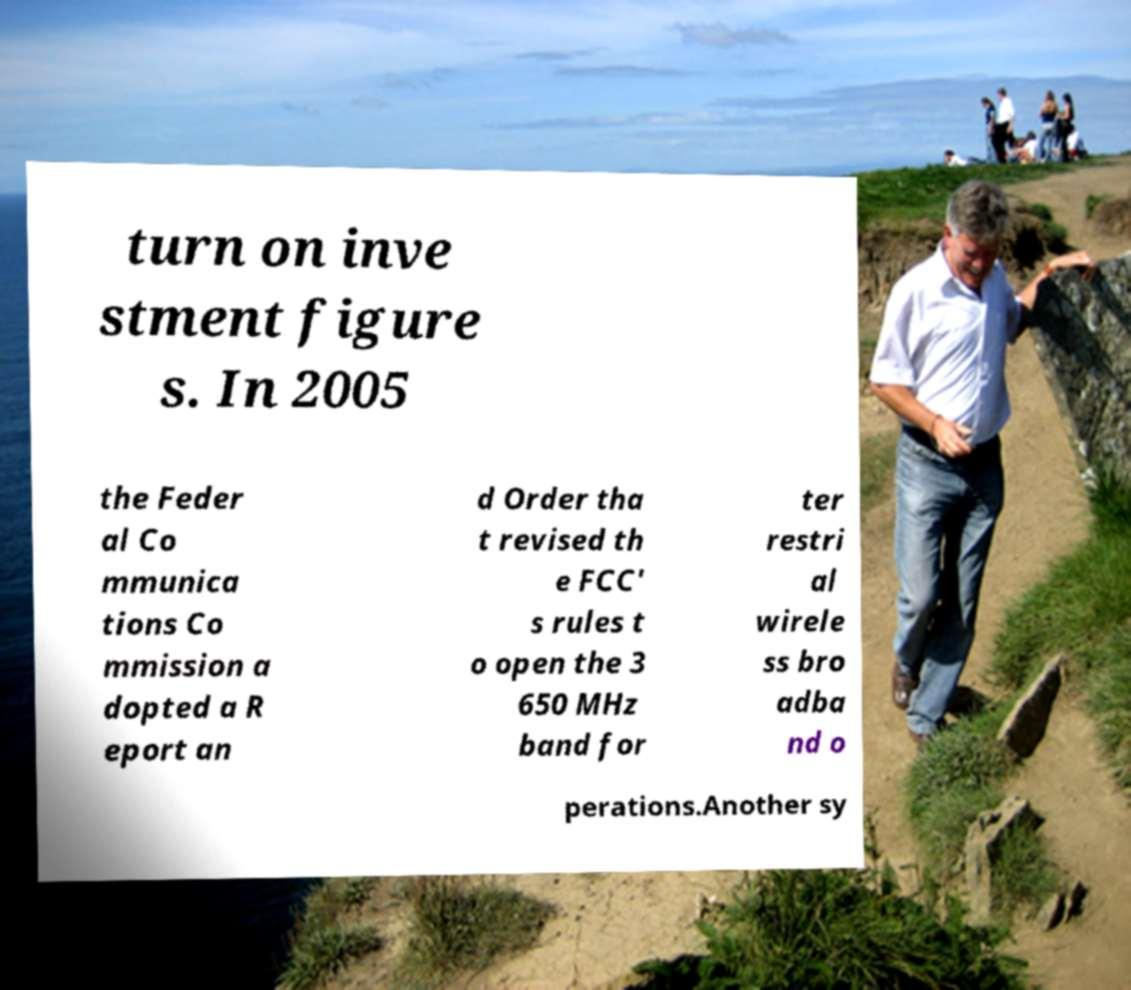Could you extract and type out the text from this image? turn on inve stment figure s. In 2005 the Feder al Co mmunica tions Co mmission a dopted a R eport an d Order tha t revised th e FCC' s rules t o open the 3 650 MHz band for ter restri al wirele ss bro adba nd o perations.Another sy 